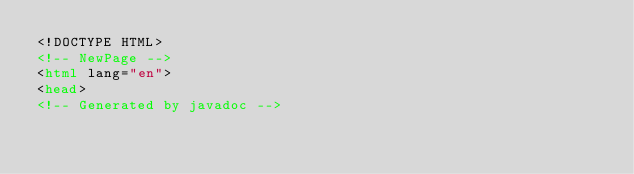Convert code to text. <code><loc_0><loc_0><loc_500><loc_500><_HTML_><!DOCTYPE HTML>
<!-- NewPage -->
<html lang="en">
<head>
<!-- Generated by javadoc --></code> 